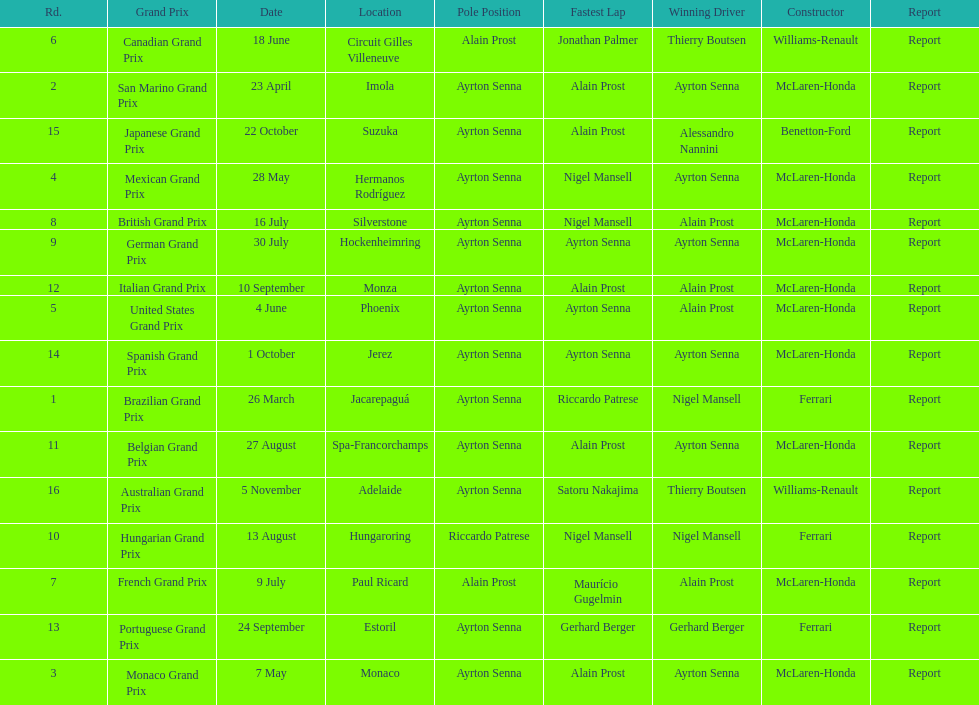How many did alain prost have the fastest lap? 5. 